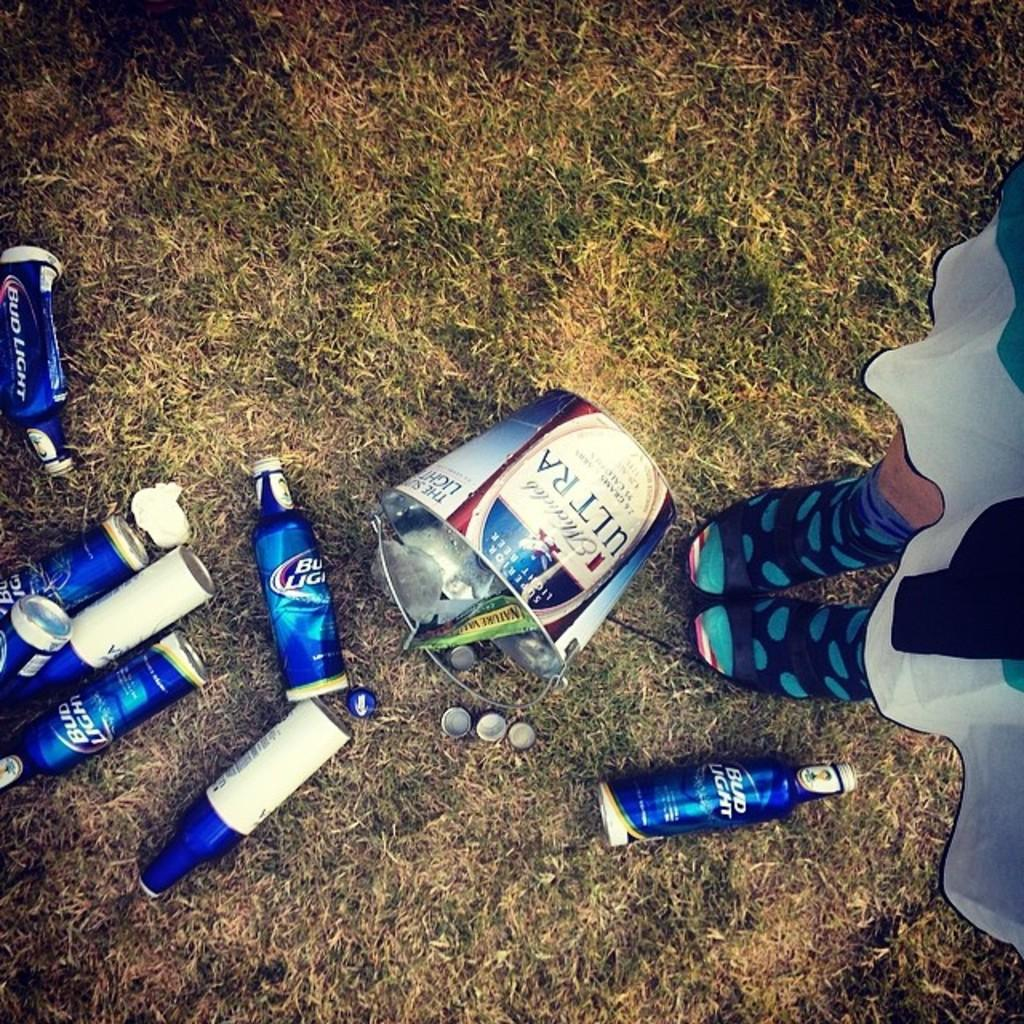What type of containers are present in the image? There are bottles and a bucket in the image. Where are the bottles and bucket located? The bottles and bucket are on the grass. Can you describe any other objects or features in the image? Human legs are visible on the left side of the image. What language is being spoken by the thunder in the image? There is no thunder present in the image, and therefore no language can be associated with it. 